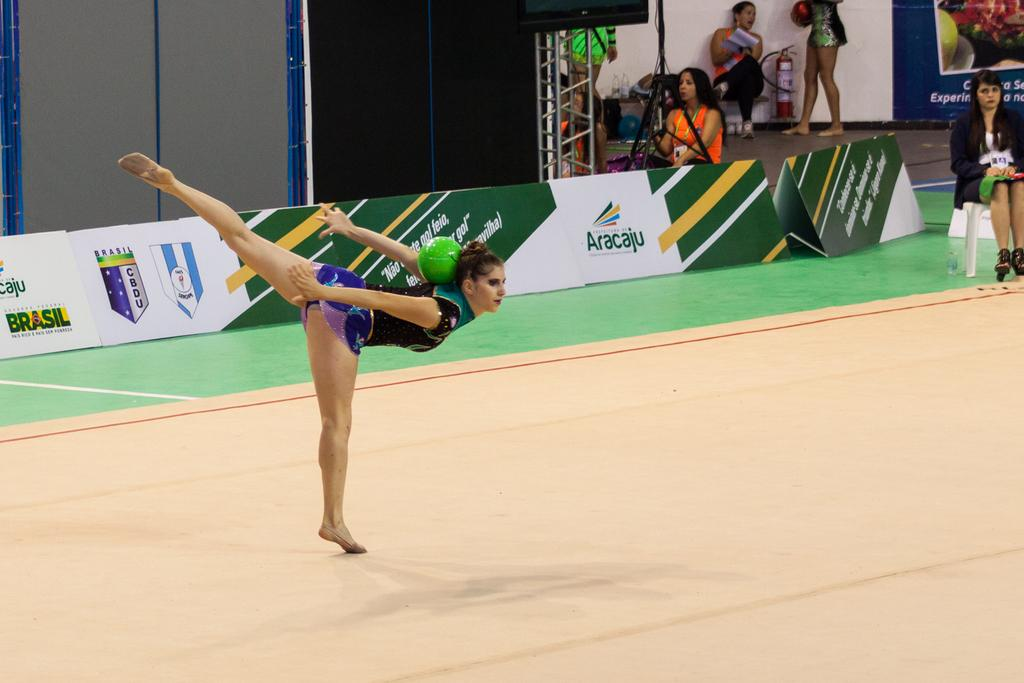<image>
Summarize the visual content of the image. A dancer poses in front of signs for Aracaju and Brasil CBDU. 